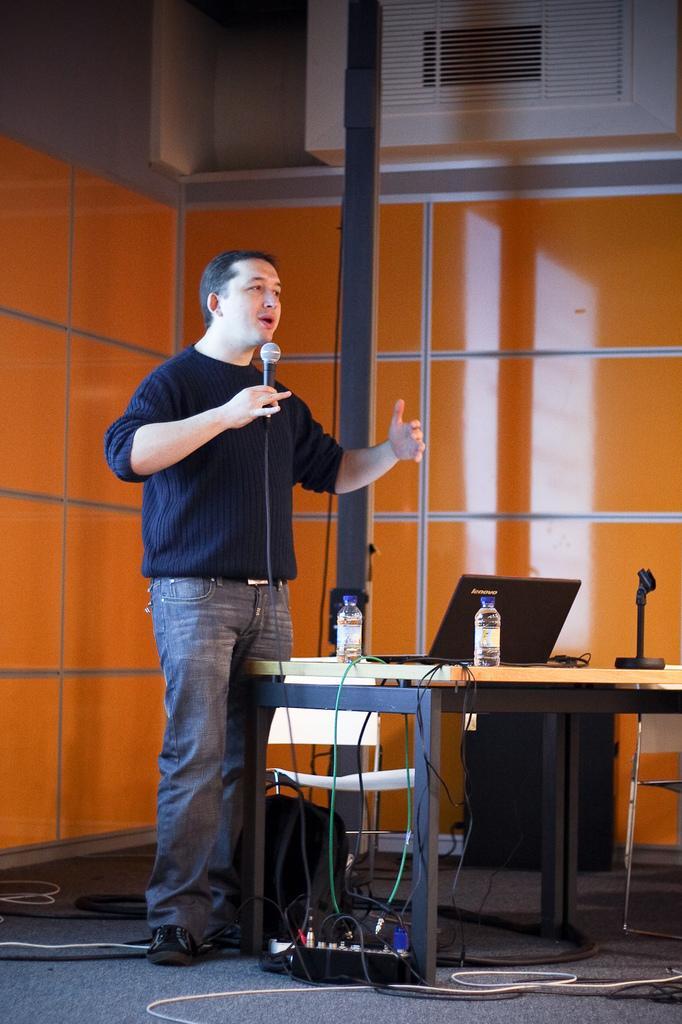Can you describe this image briefly? In this picture we can see a man who is standing on the floor. He is holding a mike with his hand. This is table. On the table there are bottles, laptop, and a mike. On the background there is a wall. This is pole. Here we can see some cables. 